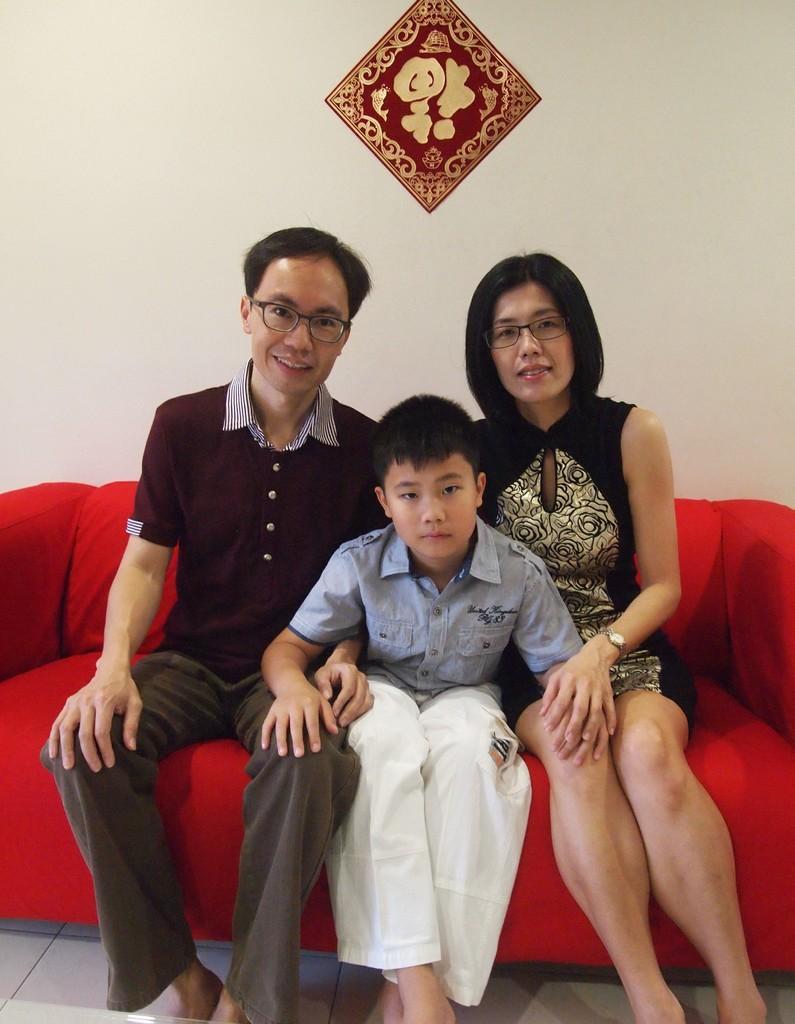Describe this image in one or two sentences. In this image a person, boy and a woman are sitting in the sofa which is in red color. Background there is a wall having a frame attached to it. 